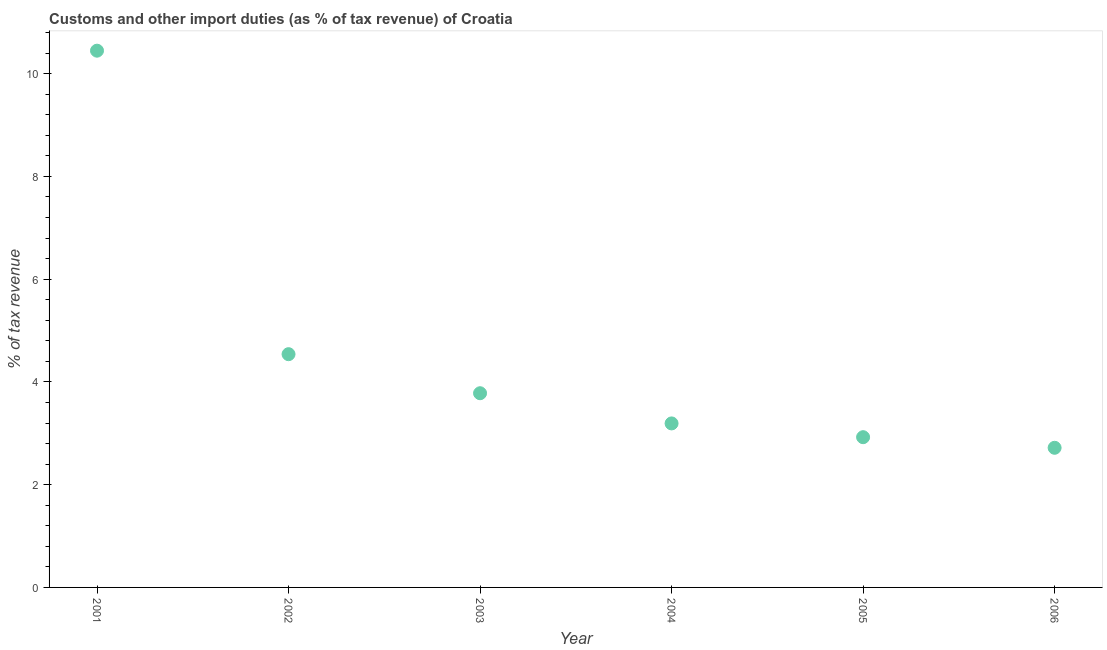What is the customs and other import duties in 2001?
Your answer should be compact. 10.45. Across all years, what is the maximum customs and other import duties?
Offer a terse response. 10.45. Across all years, what is the minimum customs and other import duties?
Your answer should be compact. 2.72. In which year was the customs and other import duties minimum?
Provide a succinct answer. 2006. What is the sum of the customs and other import duties?
Give a very brief answer. 27.6. What is the difference between the customs and other import duties in 2002 and 2006?
Offer a very short reply. 1.82. What is the average customs and other import duties per year?
Your answer should be very brief. 4.6. What is the median customs and other import duties?
Offer a terse response. 3.49. Do a majority of the years between 2005 and 2006 (inclusive) have customs and other import duties greater than 3.6 %?
Your answer should be very brief. No. What is the ratio of the customs and other import duties in 2002 to that in 2006?
Offer a very short reply. 1.67. What is the difference between the highest and the second highest customs and other import duties?
Make the answer very short. 5.91. What is the difference between the highest and the lowest customs and other import duties?
Your answer should be compact. 7.73. In how many years, is the customs and other import duties greater than the average customs and other import duties taken over all years?
Make the answer very short. 1. Does the customs and other import duties monotonically increase over the years?
Provide a succinct answer. No. How many dotlines are there?
Provide a short and direct response. 1. What is the difference between two consecutive major ticks on the Y-axis?
Provide a succinct answer. 2. Are the values on the major ticks of Y-axis written in scientific E-notation?
Provide a short and direct response. No. Does the graph contain any zero values?
Give a very brief answer. No. What is the title of the graph?
Keep it short and to the point. Customs and other import duties (as % of tax revenue) of Croatia. What is the label or title of the X-axis?
Your answer should be very brief. Year. What is the label or title of the Y-axis?
Provide a succinct answer. % of tax revenue. What is the % of tax revenue in 2001?
Your answer should be compact. 10.45. What is the % of tax revenue in 2002?
Your answer should be very brief. 4.54. What is the % of tax revenue in 2003?
Your response must be concise. 3.78. What is the % of tax revenue in 2004?
Provide a succinct answer. 3.19. What is the % of tax revenue in 2005?
Make the answer very short. 2.92. What is the % of tax revenue in 2006?
Your answer should be very brief. 2.72. What is the difference between the % of tax revenue in 2001 and 2002?
Provide a succinct answer. 5.91. What is the difference between the % of tax revenue in 2001 and 2003?
Keep it short and to the point. 6.67. What is the difference between the % of tax revenue in 2001 and 2004?
Keep it short and to the point. 7.25. What is the difference between the % of tax revenue in 2001 and 2005?
Offer a very short reply. 7.52. What is the difference between the % of tax revenue in 2001 and 2006?
Your answer should be compact. 7.73. What is the difference between the % of tax revenue in 2002 and 2003?
Your answer should be very brief. 0.76. What is the difference between the % of tax revenue in 2002 and 2004?
Offer a very short reply. 1.35. What is the difference between the % of tax revenue in 2002 and 2005?
Give a very brief answer. 1.62. What is the difference between the % of tax revenue in 2002 and 2006?
Keep it short and to the point. 1.82. What is the difference between the % of tax revenue in 2003 and 2004?
Keep it short and to the point. 0.59. What is the difference between the % of tax revenue in 2003 and 2005?
Your response must be concise. 0.86. What is the difference between the % of tax revenue in 2003 and 2006?
Make the answer very short. 1.06. What is the difference between the % of tax revenue in 2004 and 2005?
Your answer should be very brief. 0.27. What is the difference between the % of tax revenue in 2004 and 2006?
Ensure brevity in your answer.  0.47. What is the difference between the % of tax revenue in 2005 and 2006?
Ensure brevity in your answer.  0.21. What is the ratio of the % of tax revenue in 2001 to that in 2002?
Give a very brief answer. 2.3. What is the ratio of the % of tax revenue in 2001 to that in 2003?
Provide a short and direct response. 2.76. What is the ratio of the % of tax revenue in 2001 to that in 2004?
Offer a very short reply. 3.27. What is the ratio of the % of tax revenue in 2001 to that in 2005?
Ensure brevity in your answer.  3.57. What is the ratio of the % of tax revenue in 2001 to that in 2006?
Provide a succinct answer. 3.84. What is the ratio of the % of tax revenue in 2002 to that in 2003?
Provide a short and direct response. 1.2. What is the ratio of the % of tax revenue in 2002 to that in 2004?
Make the answer very short. 1.42. What is the ratio of the % of tax revenue in 2002 to that in 2005?
Offer a terse response. 1.55. What is the ratio of the % of tax revenue in 2002 to that in 2006?
Your response must be concise. 1.67. What is the ratio of the % of tax revenue in 2003 to that in 2004?
Offer a very short reply. 1.18. What is the ratio of the % of tax revenue in 2003 to that in 2005?
Keep it short and to the point. 1.29. What is the ratio of the % of tax revenue in 2003 to that in 2006?
Provide a succinct answer. 1.39. What is the ratio of the % of tax revenue in 2004 to that in 2005?
Your answer should be compact. 1.09. What is the ratio of the % of tax revenue in 2004 to that in 2006?
Your answer should be very brief. 1.18. What is the ratio of the % of tax revenue in 2005 to that in 2006?
Ensure brevity in your answer.  1.08. 